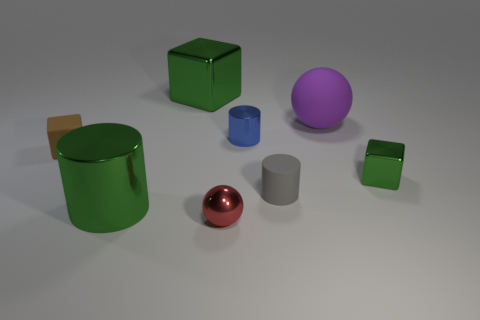Add 1 tiny brown matte things. How many objects exist? 9 Subtract all cylinders. How many objects are left? 5 Subtract all cyan cylinders. Subtract all small metal cubes. How many objects are left? 7 Add 8 tiny red metal spheres. How many tiny red metal spheres are left? 9 Add 6 small rubber things. How many small rubber things exist? 8 Subtract 2 green blocks. How many objects are left? 6 